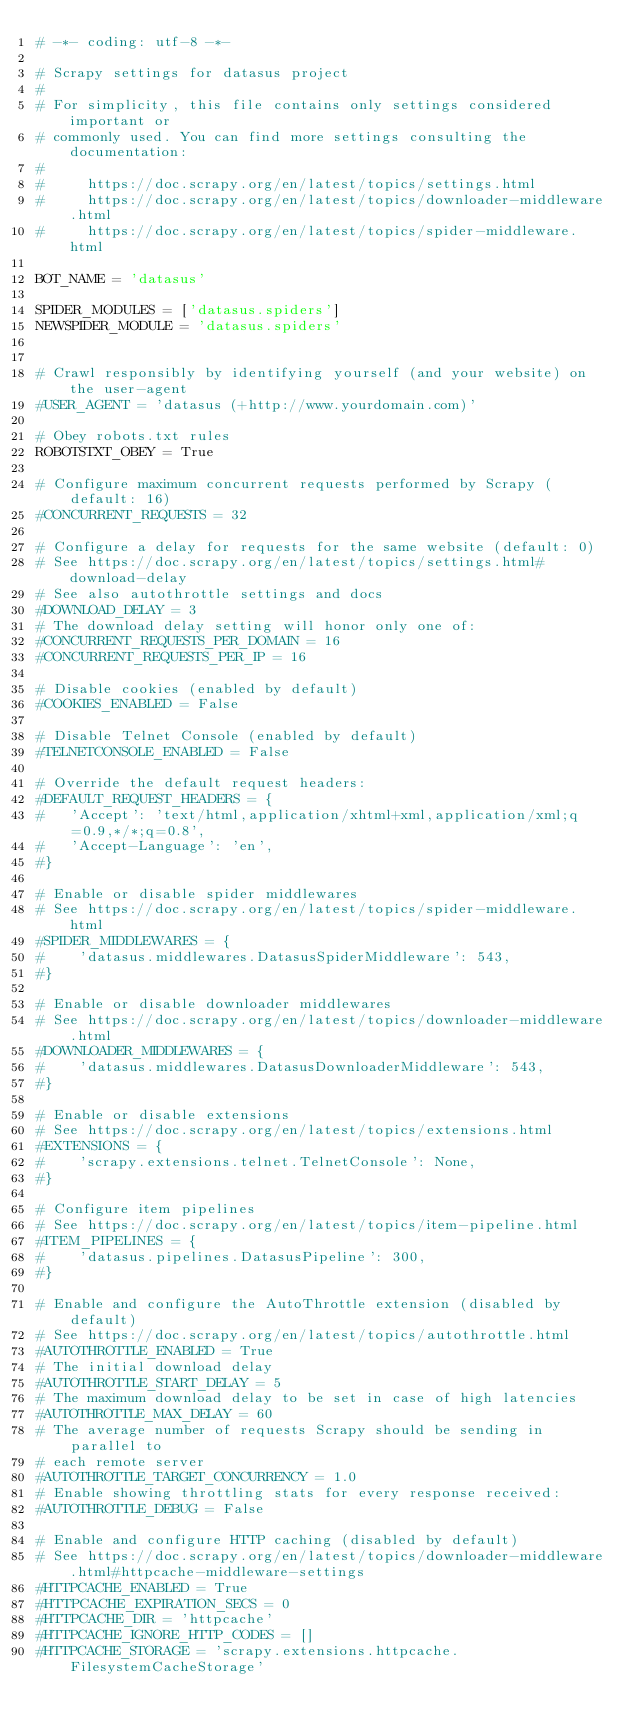Convert code to text. <code><loc_0><loc_0><loc_500><loc_500><_Python_># -*- coding: utf-8 -*-

# Scrapy settings for datasus project
#
# For simplicity, this file contains only settings considered important or
# commonly used. You can find more settings consulting the documentation:
#
#     https://doc.scrapy.org/en/latest/topics/settings.html
#     https://doc.scrapy.org/en/latest/topics/downloader-middleware.html
#     https://doc.scrapy.org/en/latest/topics/spider-middleware.html

BOT_NAME = 'datasus'

SPIDER_MODULES = ['datasus.spiders']
NEWSPIDER_MODULE = 'datasus.spiders'


# Crawl responsibly by identifying yourself (and your website) on the user-agent
#USER_AGENT = 'datasus (+http://www.yourdomain.com)'

# Obey robots.txt rules
ROBOTSTXT_OBEY = True

# Configure maximum concurrent requests performed by Scrapy (default: 16)
#CONCURRENT_REQUESTS = 32

# Configure a delay for requests for the same website (default: 0)
# See https://doc.scrapy.org/en/latest/topics/settings.html#download-delay
# See also autothrottle settings and docs
#DOWNLOAD_DELAY = 3
# The download delay setting will honor only one of:
#CONCURRENT_REQUESTS_PER_DOMAIN = 16
#CONCURRENT_REQUESTS_PER_IP = 16

# Disable cookies (enabled by default)
#COOKIES_ENABLED = False

# Disable Telnet Console (enabled by default)
#TELNETCONSOLE_ENABLED = False

# Override the default request headers:
#DEFAULT_REQUEST_HEADERS = {
#   'Accept': 'text/html,application/xhtml+xml,application/xml;q=0.9,*/*;q=0.8',
#   'Accept-Language': 'en',
#}

# Enable or disable spider middlewares
# See https://doc.scrapy.org/en/latest/topics/spider-middleware.html
#SPIDER_MIDDLEWARES = {
#    'datasus.middlewares.DatasusSpiderMiddleware': 543,
#}

# Enable or disable downloader middlewares
# See https://doc.scrapy.org/en/latest/topics/downloader-middleware.html
#DOWNLOADER_MIDDLEWARES = {
#    'datasus.middlewares.DatasusDownloaderMiddleware': 543,
#}

# Enable or disable extensions
# See https://doc.scrapy.org/en/latest/topics/extensions.html
#EXTENSIONS = {
#    'scrapy.extensions.telnet.TelnetConsole': None,
#}

# Configure item pipelines
# See https://doc.scrapy.org/en/latest/topics/item-pipeline.html
#ITEM_PIPELINES = {
#    'datasus.pipelines.DatasusPipeline': 300,
#}

# Enable and configure the AutoThrottle extension (disabled by default)
# See https://doc.scrapy.org/en/latest/topics/autothrottle.html
#AUTOTHROTTLE_ENABLED = True
# The initial download delay
#AUTOTHROTTLE_START_DELAY = 5
# The maximum download delay to be set in case of high latencies
#AUTOTHROTTLE_MAX_DELAY = 60
# The average number of requests Scrapy should be sending in parallel to
# each remote server
#AUTOTHROTTLE_TARGET_CONCURRENCY = 1.0
# Enable showing throttling stats for every response received:
#AUTOTHROTTLE_DEBUG = False

# Enable and configure HTTP caching (disabled by default)
# See https://doc.scrapy.org/en/latest/topics/downloader-middleware.html#httpcache-middleware-settings
#HTTPCACHE_ENABLED = True
#HTTPCACHE_EXPIRATION_SECS = 0
#HTTPCACHE_DIR = 'httpcache'
#HTTPCACHE_IGNORE_HTTP_CODES = []
#HTTPCACHE_STORAGE = 'scrapy.extensions.httpcache.FilesystemCacheStorage'
</code> 